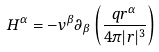Convert formula to latex. <formula><loc_0><loc_0><loc_500><loc_500>H ^ { \alpha } = - v ^ { \beta } \partial _ { \beta } \left ( \frac { q r ^ { \alpha } } { 4 \pi | r | ^ { 3 } } \right )</formula> 